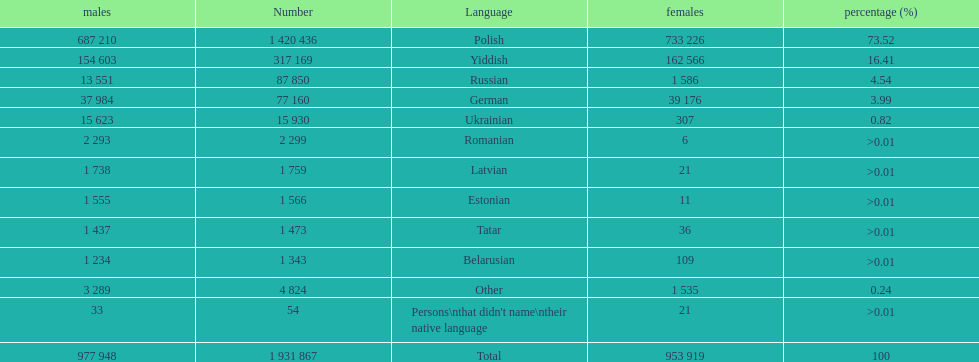Which language had the most number of people speaking it. Polish. 